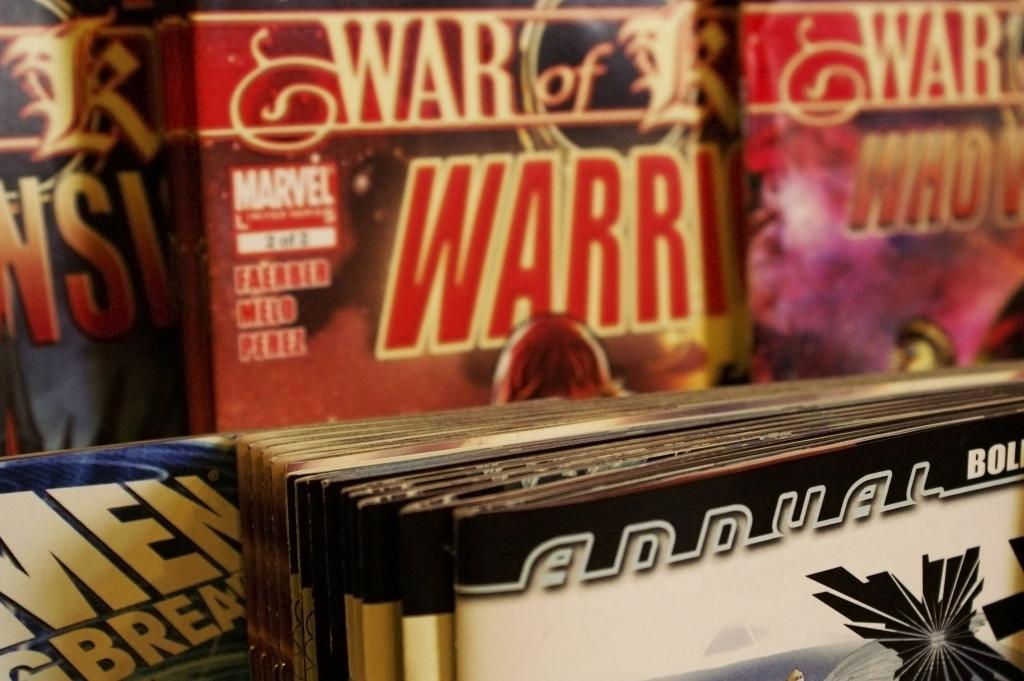<image>
Write a terse but informative summary of the picture. Stacks of comic books sit on display for the Marvel Comics company. 